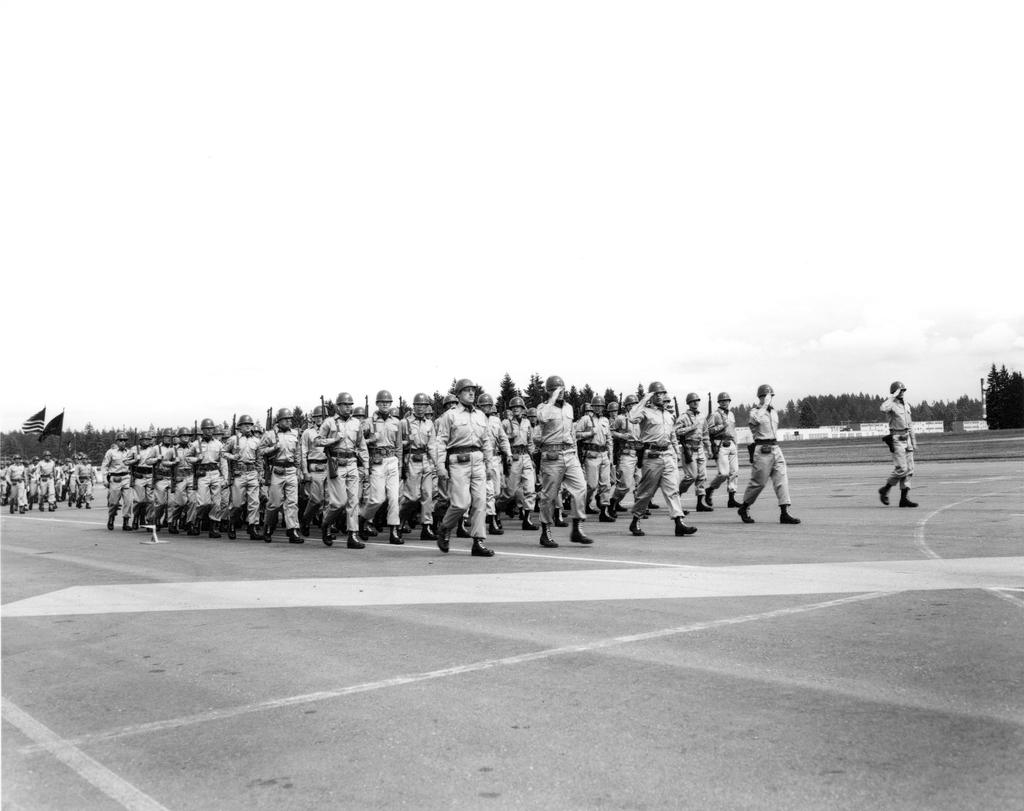What are the people in the image doing? The people in the image are walking on the road. What can be seen in addition to the people walking? There are flags visible, as well as trees, a wall, and the sky in the background. What type of pan can be seen in the image? There is no pan present in the image. Can you hear the people in the image crying? The image is silent, and there is no indication that the people are crying. 